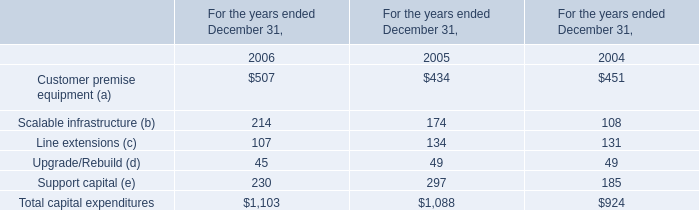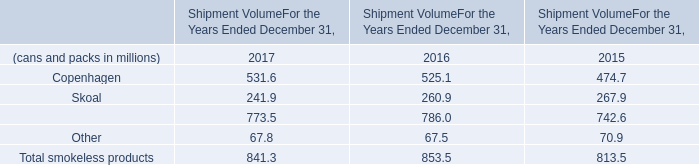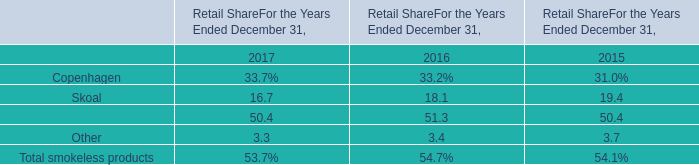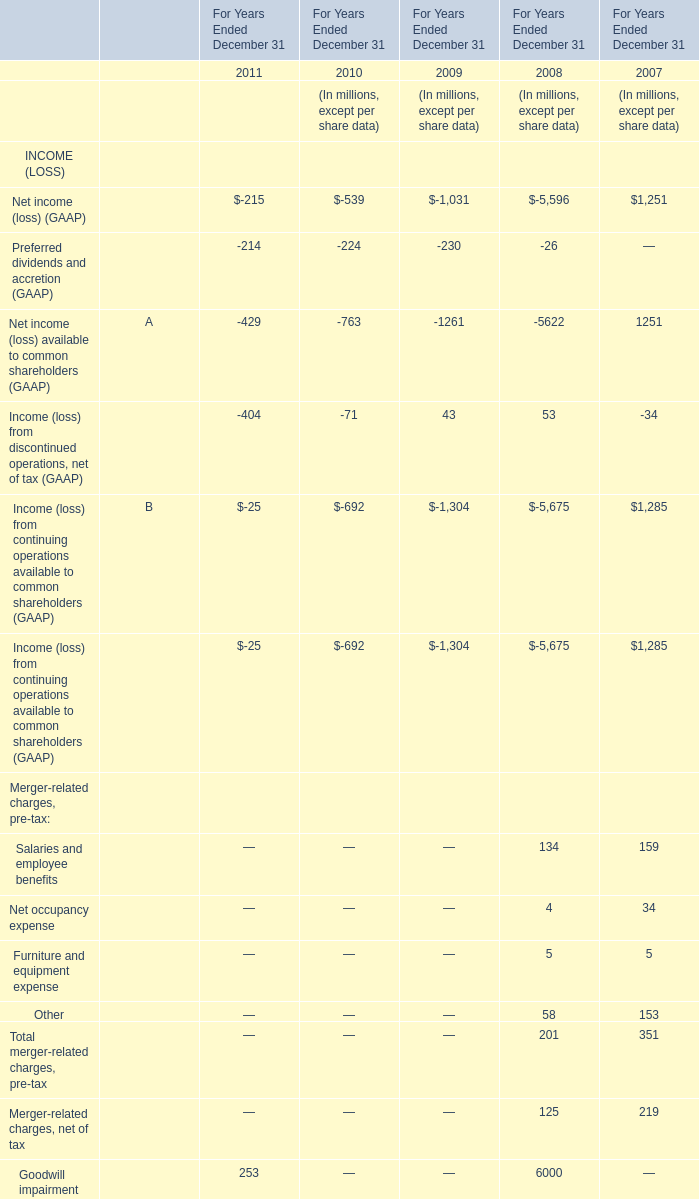Which year is Income (loss) from discontinued operations, net of tax (GAAP) the most? 
Answer: 2008. 